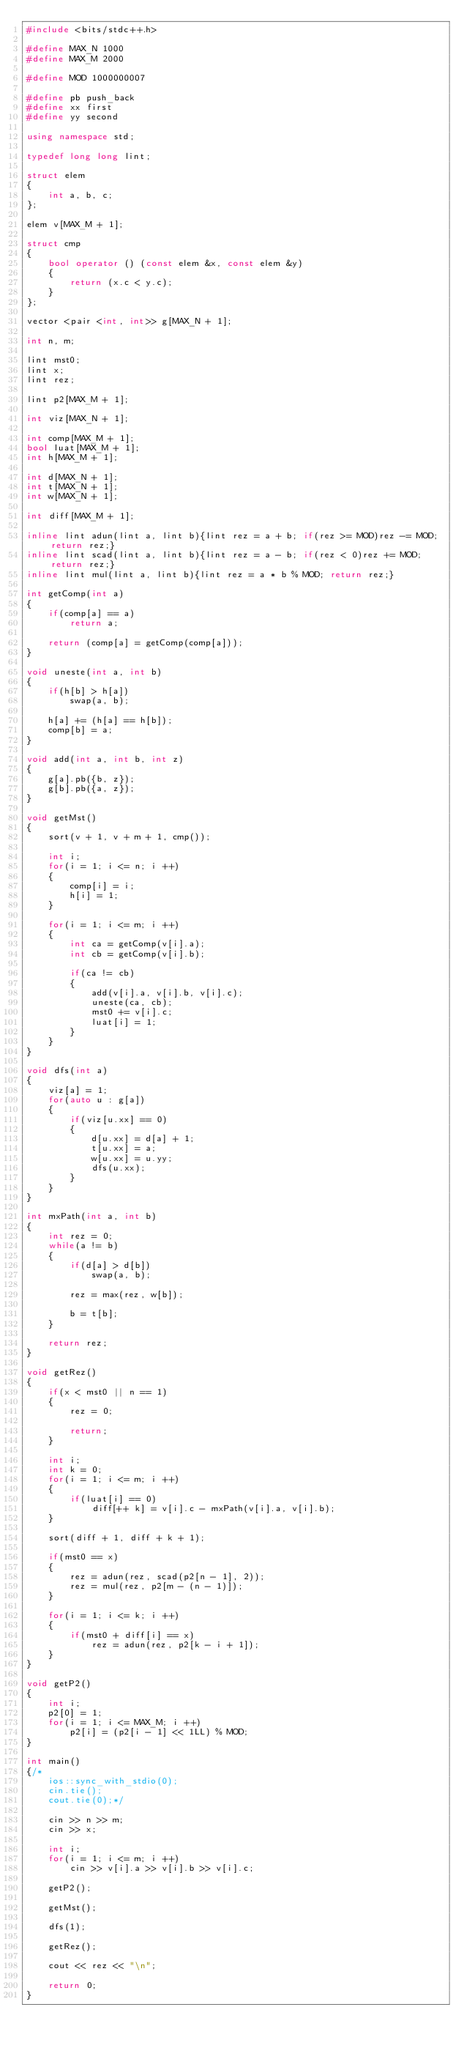<code> <loc_0><loc_0><loc_500><loc_500><_C++_>#include <bits/stdc++.h>

#define MAX_N 1000
#define MAX_M 2000

#define MOD 1000000007

#define pb push_back
#define xx first
#define yy second

using namespace std;

typedef long long lint;

struct elem
{
    int a, b, c;
};

elem v[MAX_M + 1];

struct cmp
{
    bool operator () (const elem &x, const elem &y)
    {
        return (x.c < y.c);
    }
};

vector <pair <int, int>> g[MAX_N + 1];

int n, m;

lint mst0;
lint x;
lint rez;

lint p2[MAX_M + 1];

int viz[MAX_N + 1];

int comp[MAX_M + 1];
bool luat[MAX_M + 1];
int h[MAX_M + 1];

int d[MAX_N + 1];
int t[MAX_N + 1];
int w[MAX_N + 1];

int diff[MAX_M + 1];

inline lint adun(lint a, lint b){lint rez = a + b; if(rez >= MOD)rez -= MOD; return rez;}
inline lint scad(lint a, lint b){lint rez = a - b; if(rez < 0)rez += MOD; return rez;}
inline lint mul(lint a, lint b){lint rez = a * b % MOD; return rez;}

int getComp(int a)
{
    if(comp[a] == a)
        return a;

    return (comp[a] = getComp(comp[a]));
}

void uneste(int a, int b)
{
    if(h[b] > h[a])
        swap(a, b);

    h[a] += (h[a] == h[b]);
    comp[b] = a;
}

void add(int a, int b, int z)
{
    g[a].pb({b, z});
    g[b].pb({a, z});
}

void getMst()
{
    sort(v + 1, v + m + 1, cmp());

    int i;
    for(i = 1; i <= n; i ++)
    {
        comp[i] = i;
        h[i] = 1;
    }

    for(i = 1; i <= m; i ++)
    {
        int ca = getComp(v[i].a);
        int cb = getComp(v[i].b);

        if(ca != cb)
        {
            add(v[i].a, v[i].b, v[i].c);
            uneste(ca, cb);
            mst0 += v[i].c;
            luat[i] = 1;
        }
    }
}

void dfs(int a)
{
    viz[a] = 1;
    for(auto u : g[a])
    {
        if(viz[u.xx] == 0)
        {
            d[u.xx] = d[a] + 1;
            t[u.xx] = a;
            w[u.xx] = u.yy;
            dfs(u.xx);
        }
    }
}

int mxPath(int a, int b)
{
    int rez = 0;
    while(a != b)
    {
        if(d[a] > d[b])
            swap(a, b);

        rez = max(rez, w[b]);

        b = t[b];
    }

    return rez;
}

void getRez()
{
    if(x < mst0 || n == 1)
    {
        rez = 0;

        return;
    }

    int i;
    int k = 0;
    for(i = 1; i <= m; i ++)
    {
        if(luat[i] == 0)
            diff[++ k] = v[i].c - mxPath(v[i].a, v[i].b);
    }

    sort(diff + 1, diff + k + 1);

    if(mst0 == x)
    {
        rez = adun(rez, scad(p2[n - 1], 2));
        rez = mul(rez, p2[m - (n - 1)]);
    }

    for(i = 1; i <= k; i ++)
    {
        if(mst0 + diff[i] == x)
            rez = adun(rez, p2[k - i + 1]);
    }
}

void getP2()
{
    int i;
    p2[0] = 1;
    for(i = 1; i <= MAX_M; i ++)
        p2[i] = (p2[i - 1] << 1LL) % MOD;
}

int main()
{/*
    ios::sync_with_stdio(0);
    cin.tie();
    cout.tie(0);*/

    cin >> n >> m;
    cin >> x;

    int i;
    for(i = 1; i <= m; i ++)
        cin >> v[i].a >> v[i].b >> v[i].c;

    getP2();

    getMst();

    dfs(1);

    getRez();

    cout << rez << "\n";

    return 0;
}
</code> 